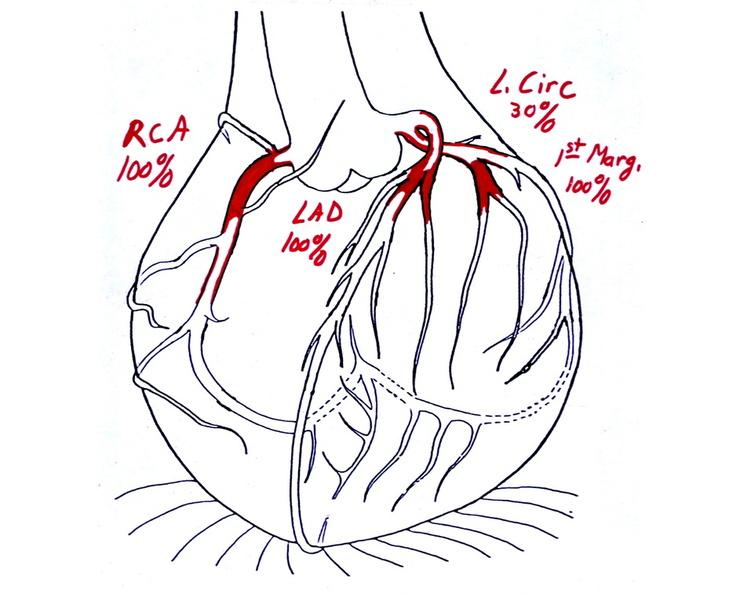s cardiovascular present?
Answer the question using a single word or phrase. Yes 